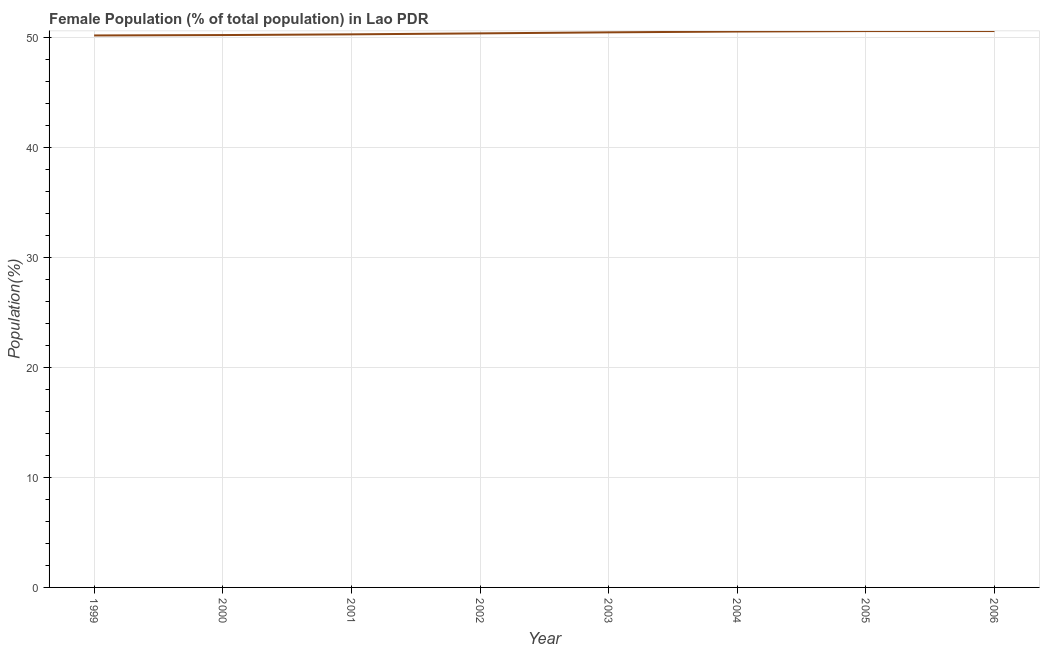What is the female population in 2004?
Keep it short and to the point. 50.52. Across all years, what is the maximum female population?
Your response must be concise. 50.56. Across all years, what is the minimum female population?
Offer a very short reply. 50.16. In which year was the female population maximum?
Offer a very short reply. 2006. In which year was the female population minimum?
Keep it short and to the point. 1999. What is the sum of the female population?
Your response must be concise. 403.03. What is the difference between the female population in 2001 and 2004?
Make the answer very short. -0.26. What is the average female population per year?
Make the answer very short. 50.38. What is the median female population?
Give a very brief answer. 50.39. In how many years, is the female population greater than 42 %?
Offer a terse response. 8. Do a majority of the years between 2001 and 2000 (inclusive) have female population greater than 14 %?
Keep it short and to the point. No. What is the ratio of the female population in 2001 to that in 2005?
Offer a terse response. 0.99. Is the female population in 2000 less than that in 2004?
Your response must be concise. Yes. What is the difference between the highest and the second highest female population?
Offer a terse response. 0. Is the sum of the female population in 1999 and 2005 greater than the maximum female population across all years?
Your answer should be very brief. Yes. What is the difference between the highest and the lowest female population?
Offer a terse response. 0.4. Does the female population monotonically increase over the years?
Provide a short and direct response. Yes. How many lines are there?
Your answer should be compact. 1. How many years are there in the graph?
Offer a very short reply. 8. Does the graph contain any zero values?
Keep it short and to the point. No. What is the title of the graph?
Make the answer very short. Female Population (% of total population) in Lao PDR. What is the label or title of the X-axis?
Provide a short and direct response. Year. What is the label or title of the Y-axis?
Make the answer very short. Population(%). What is the Population(%) of 1999?
Your answer should be compact. 50.16. What is the Population(%) of 2000?
Your response must be concise. 50.19. What is the Population(%) of 2001?
Make the answer very short. 50.26. What is the Population(%) in 2002?
Offer a terse response. 50.35. What is the Population(%) of 2003?
Keep it short and to the point. 50.44. What is the Population(%) in 2004?
Provide a short and direct response. 50.52. What is the Population(%) in 2005?
Keep it short and to the point. 50.56. What is the Population(%) in 2006?
Give a very brief answer. 50.56. What is the difference between the Population(%) in 1999 and 2000?
Offer a very short reply. -0.03. What is the difference between the Population(%) in 1999 and 2001?
Your answer should be compact. -0.1. What is the difference between the Population(%) in 1999 and 2002?
Your answer should be very brief. -0.19. What is the difference between the Population(%) in 1999 and 2003?
Your answer should be compact. -0.28. What is the difference between the Population(%) in 1999 and 2004?
Offer a terse response. -0.36. What is the difference between the Population(%) in 1999 and 2005?
Offer a terse response. -0.4. What is the difference between the Population(%) in 1999 and 2006?
Make the answer very short. -0.4. What is the difference between the Population(%) in 2000 and 2001?
Your answer should be very brief. -0.07. What is the difference between the Population(%) in 2000 and 2002?
Provide a succinct answer. -0.15. What is the difference between the Population(%) in 2000 and 2003?
Offer a terse response. -0.25. What is the difference between the Population(%) in 2000 and 2004?
Provide a succinct answer. -0.32. What is the difference between the Population(%) in 2000 and 2005?
Your response must be concise. -0.36. What is the difference between the Population(%) in 2000 and 2006?
Provide a short and direct response. -0.37. What is the difference between the Population(%) in 2001 and 2002?
Your response must be concise. -0.09. What is the difference between the Population(%) in 2001 and 2003?
Offer a very short reply. -0.18. What is the difference between the Population(%) in 2001 and 2004?
Ensure brevity in your answer.  -0.26. What is the difference between the Population(%) in 2001 and 2005?
Provide a succinct answer. -0.3. What is the difference between the Population(%) in 2001 and 2006?
Offer a very short reply. -0.3. What is the difference between the Population(%) in 2002 and 2003?
Provide a succinct answer. -0.09. What is the difference between the Population(%) in 2002 and 2004?
Your answer should be very brief. -0.17. What is the difference between the Population(%) in 2002 and 2005?
Provide a short and direct response. -0.21. What is the difference between the Population(%) in 2002 and 2006?
Your answer should be compact. -0.21. What is the difference between the Population(%) in 2003 and 2004?
Give a very brief answer. -0.08. What is the difference between the Population(%) in 2003 and 2005?
Your response must be concise. -0.12. What is the difference between the Population(%) in 2003 and 2006?
Offer a very short reply. -0.12. What is the difference between the Population(%) in 2004 and 2005?
Keep it short and to the point. -0.04. What is the difference between the Population(%) in 2004 and 2006?
Your answer should be very brief. -0.04. What is the difference between the Population(%) in 2005 and 2006?
Offer a terse response. -0. What is the ratio of the Population(%) in 1999 to that in 2000?
Offer a terse response. 1. What is the ratio of the Population(%) in 1999 to that in 2002?
Provide a short and direct response. 1. What is the ratio of the Population(%) in 1999 to that in 2006?
Offer a terse response. 0.99. What is the ratio of the Population(%) in 2000 to that in 2002?
Your answer should be very brief. 1. What is the ratio of the Population(%) in 2000 to that in 2004?
Offer a very short reply. 0.99. What is the ratio of the Population(%) in 2000 to that in 2006?
Ensure brevity in your answer.  0.99. What is the ratio of the Population(%) in 2001 to that in 2003?
Your answer should be very brief. 1. What is the ratio of the Population(%) in 2001 to that in 2004?
Keep it short and to the point. 0.99. What is the ratio of the Population(%) in 2001 to that in 2005?
Your response must be concise. 0.99. What is the ratio of the Population(%) in 2002 to that in 2004?
Your answer should be compact. 1. What is the ratio of the Population(%) in 2002 to that in 2005?
Ensure brevity in your answer.  1. What is the ratio of the Population(%) in 2002 to that in 2006?
Offer a terse response. 1. What is the ratio of the Population(%) in 2003 to that in 2004?
Your response must be concise. 1. What is the ratio of the Population(%) in 2003 to that in 2006?
Make the answer very short. 1. What is the ratio of the Population(%) in 2004 to that in 2006?
Your answer should be very brief. 1. 